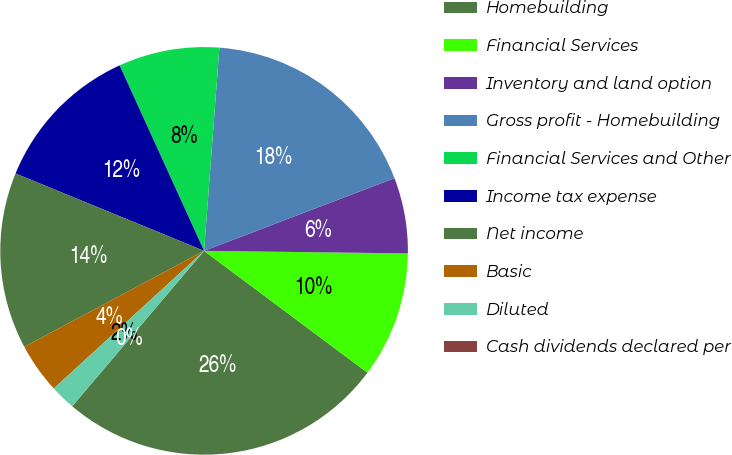<chart> <loc_0><loc_0><loc_500><loc_500><pie_chart><fcel>Homebuilding<fcel>Financial Services<fcel>Inventory and land option<fcel>Gross profit - Homebuilding<fcel>Financial Services and Other<fcel>Income tax expense<fcel>Net income<fcel>Basic<fcel>Diluted<fcel>Cash dividends declared per<nl><fcel>26.0%<fcel>10.0%<fcel>6.0%<fcel>18.0%<fcel>8.0%<fcel>12.0%<fcel>14.0%<fcel>4.0%<fcel>2.0%<fcel>0.0%<nl></chart> 